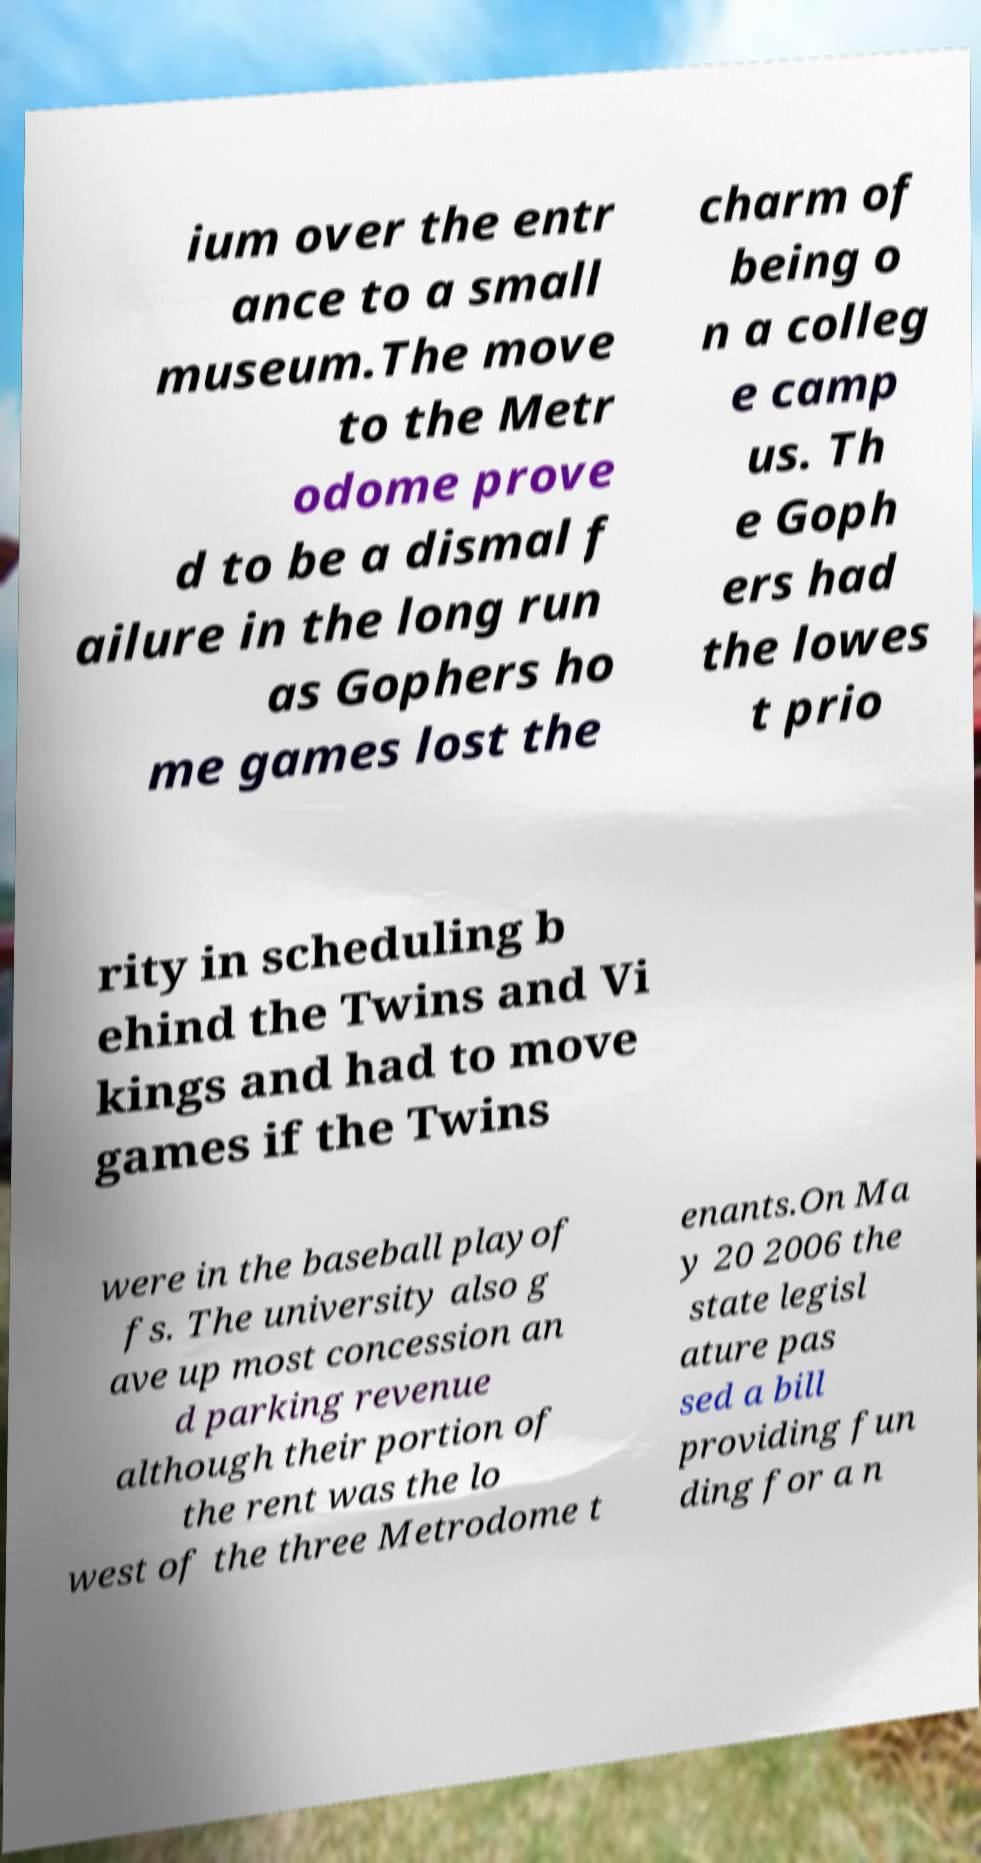I need the written content from this picture converted into text. Can you do that? ium over the entr ance to a small museum.The move to the Metr odome prove d to be a dismal f ailure in the long run as Gophers ho me games lost the charm of being o n a colleg e camp us. Th e Goph ers had the lowes t prio rity in scheduling b ehind the Twins and Vi kings and had to move games if the Twins were in the baseball playof fs. The university also g ave up most concession an d parking revenue although their portion of the rent was the lo west of the three Metrodome t enants.On Ma y 20 2006 the state legisl ature pas sed a bill providing fun ding for a n 